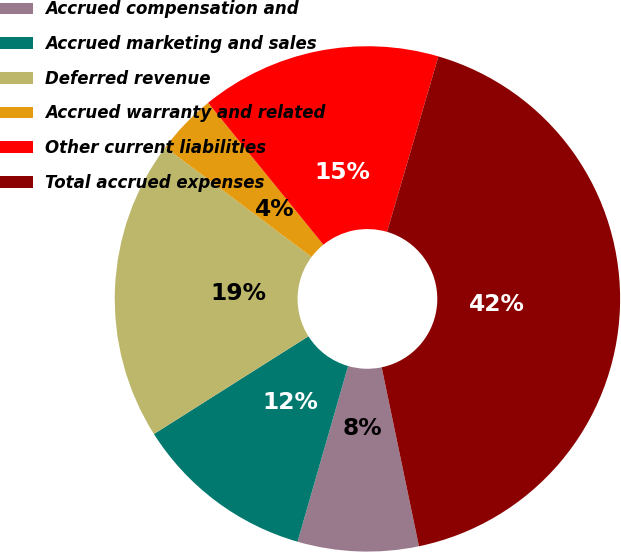<chart> <loc_0><loc_0><loc_500><loc_500><pie_chart><fcel>Accrued compensation and<fcel>Accrued marketing and sales<fcel>Deferred revenue<fcel>Accrued warranty and related<fcel>Other current liabilities<fcel>Total accrued expenses<nl><fcel>7.73%<fcel>11.56%<fcel>19.22%<fcel>3.9%<fcel>15.39%<fcel>42.2%<nl></chart> 